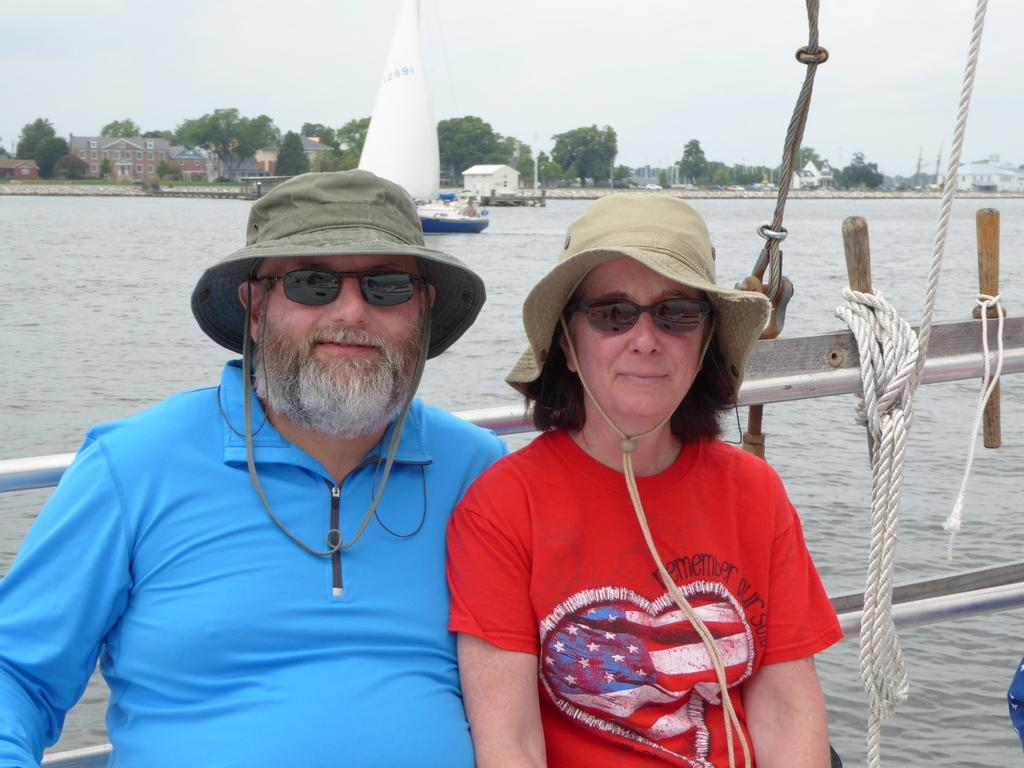How many people are present in the image? There are two people in the image, a man and a woman. What are the man and the woman wearing? Both the man and the woman are wearing goggles. What is the primary setting of the image? The image features water, a boat, and a background with houses, trees, and the sky. What type of watercraft is present in the image? There is a boat in the water. What can be seen in the background of the image? In the background of the image, there are houses, trees, and the sky. What type of thread is being used to sew the branch in the image? There is no branch or thread present in the image. What do the man and the woman believe about the water in the image? The image does not provide any information about the beliefs of the man and the woman regarding the water. 